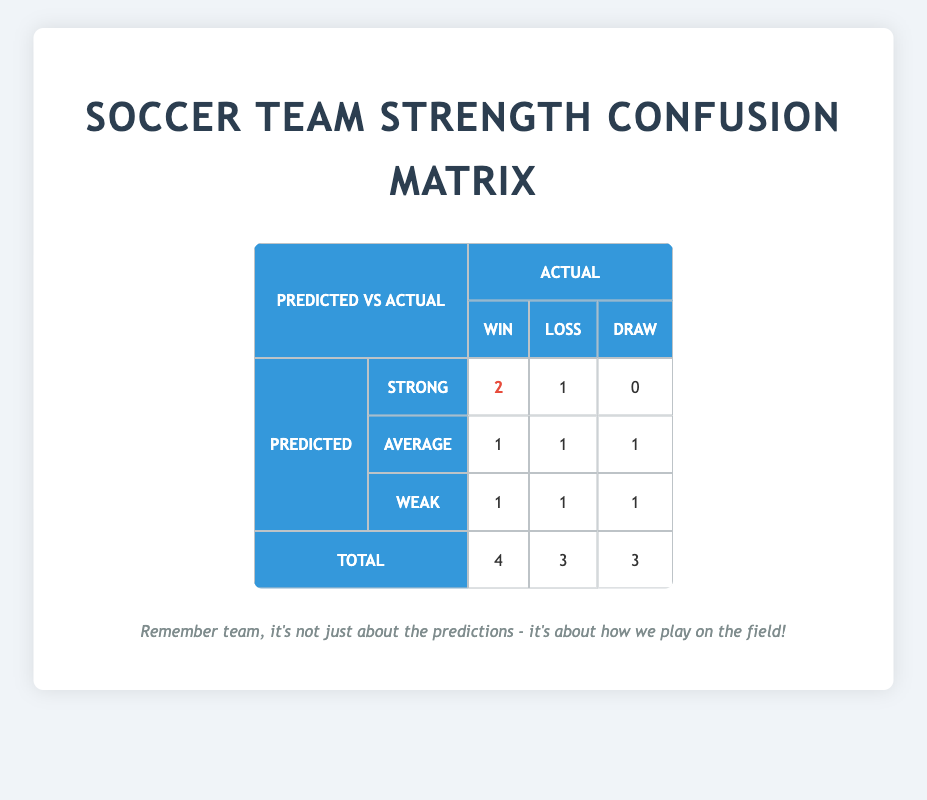What is the total number of games predicted to be a win? The table shows that the total wins from the predicted strength categories can be found by adding the values in the "Win" column. 2 (Strong) + 1 (Average) + 1 (Weak) = 4.
Answer: 4 How many teams were predicted to be of average strength? The predicted strength category of "Average" lists three teams: Maplewood High, Crescent City, and Lakeview Prep. This is directly visible in the table.
Answer: 3 Did the team predicted as "Weak" win more games than they lost? The "Weak" category shows that there was 1 win and 1 loss. Therefore, they did not win more games than they lost since the numbers are equal.
Answer: No What is the difference between the total number of wins and losses predicted? The total predicted wins is 4, and the total predicted losses is 3 (2 + 1 + 1). The difference is calculated by subtracting the total losses from the total wins: 4 - 3 = 1.
Answer: 1 Which predicted category had the highest number of wins? By examining the "Win" column, the "Strong" category has 2 wins, which is more than the "Average" (1) and "Weak" (1) categories. Thus, "Strong" has the highest number of wins.
Answer: Strong What percentage of the teams predicted as "Strong" actually won their games? There are 3 teams predicted as "Strong", and 2 of them won. To find the percentage, we calculate (2 wins / 3 teams) * 100 = approximately 66.67%.
Answer: 66.67% If the "Average" category teams had won one more game, how would this affect the total number of wins? The "Average" category currently has 1 win. If they won one more game, this would increase the total wins from 4 to 5 and losses from 3 to 3 would stay the same. Hence, it would change the total wins to 5.
Answer: 5 How many total draws are predicted for the teams labeled as "Weak"? In the "Weak" category, there is 1 draw based on the table information.
Answer: 1 Which category had the least number of total losses? The "Weak" category has 1 loss compared to the "Average" category with 1 loss and the "Strong" category with 1 loss. Therefore all categories have the same number of total losses, which is 1 each.
Answer: All categories have the same number of losses 